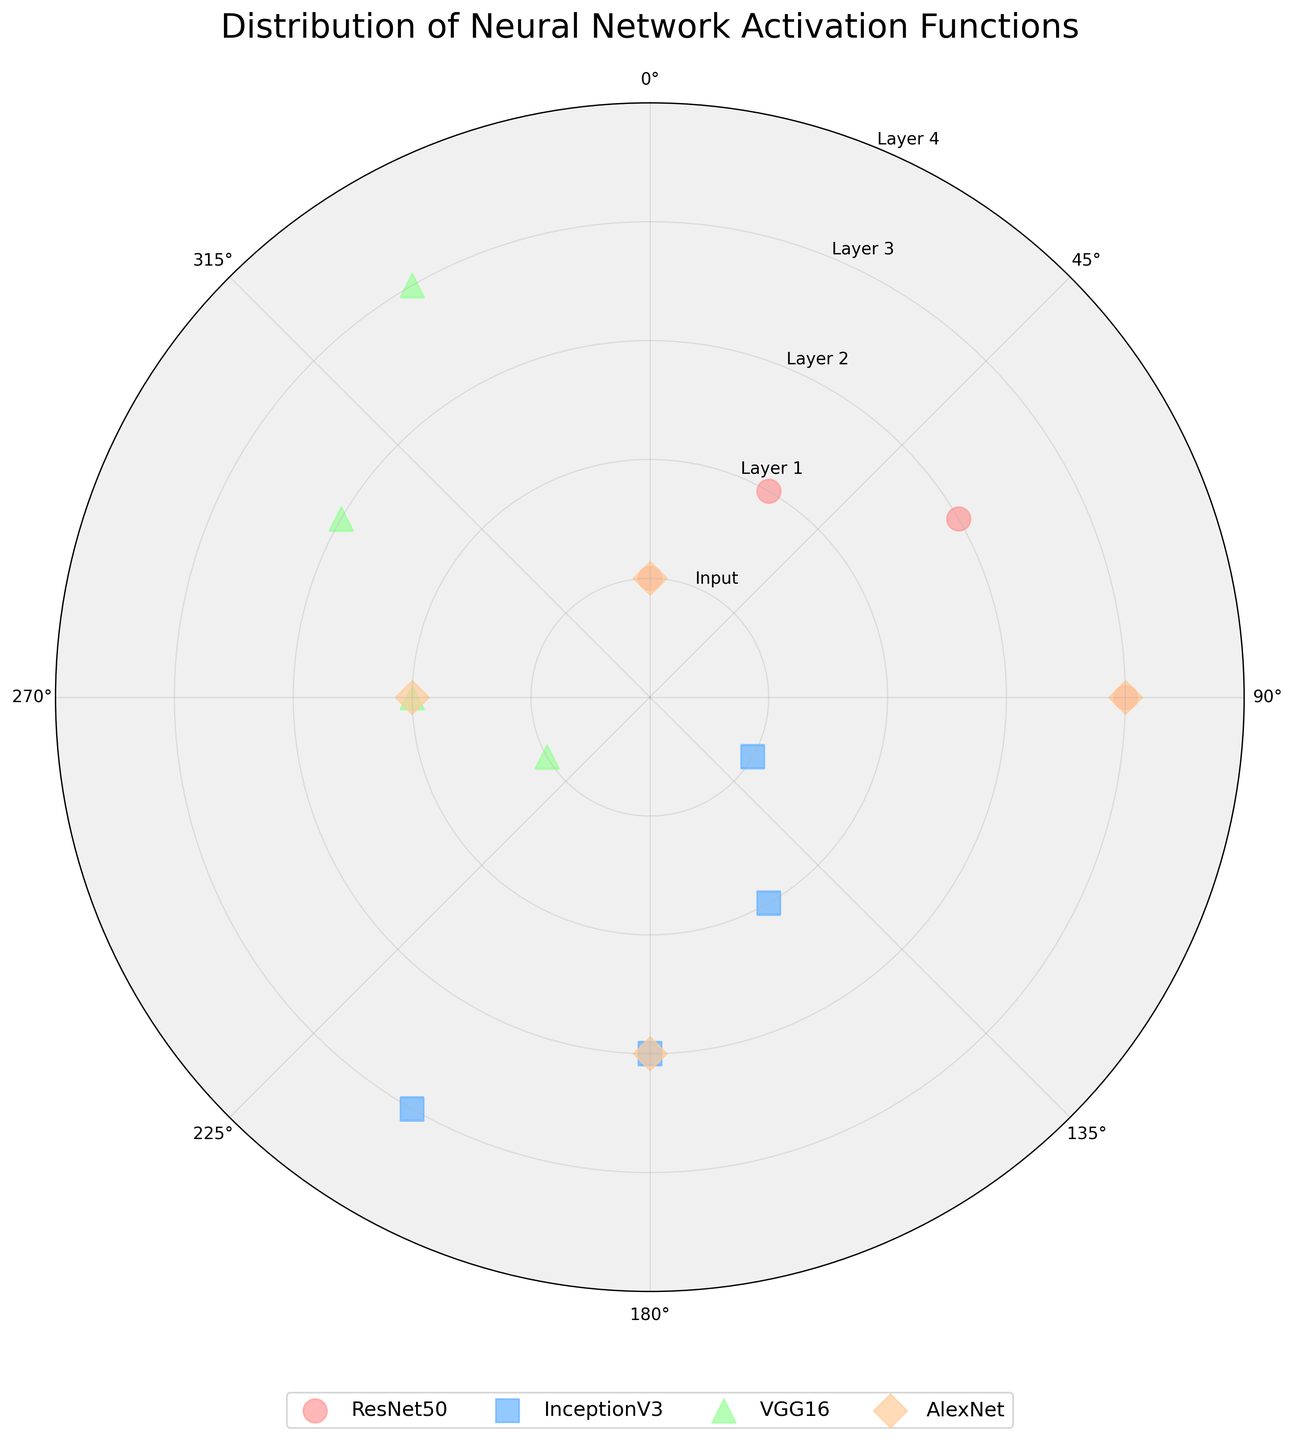what is the title of the chart? The title of the chart is located at the top center and can be directly read from the plot.
Answer: Distribution of Neural Network Activation Functions How many unique architectures are displayed in the chart? You can count the different colors and markers indicated in the legend at the bottom of the chart.
Answer: 4 Which architecture uses a diamond (♦) marker? The legend shows that the diamond marker represents the AlexNet architecture.
Answer: AlexNet What is the radius value for the Conv2 layer in the ResNet50 architecture? Following the orange circles for ResNet50, the Conv2 layer is plotted at a radius of 3.
Answer: 3 How many layers in the InceptionV3 architecture have an activation function labeled? By counting the blue squares in the scatter plot, there are four layers for InceptionV3.
Answer: 4 Compare the radii of the Conv1 layers in ResNet50 and AlexNet. Which one is greater? The radius for Conv1 in ResNet50 is 2 and in AlexNet is also 2, so they are equal.
Answer: Equal Which layer has the highest activation function value in the VGG16 architecture? Among the green triangles, the layer with the highest radial value is Conv2_1 at a radius of 4.
Answer: Conv2_1 What is the angular position (theta) for the Mixed6a layer in InceptionV3? From the chart, the angular position (theta) for Mixed6a in InceptionV3 is 210 degrees.
Answer: 210 Identify the architecture with the most distant layer from the center and name the layer. By noting the maximum radius value, the FullyConnected layer in AlexNet at radius 4 is the most distant from the center.
Answer: AlexNet, FullyConnected How many layers of ResNet50 architecture have activation functions plotted between 0 and 90 degrees theta? Counting the orange circles within the 0 to 90 degrees angular range, there are three such layers: Input, Conv1, and Conv2.
Answer: 3 